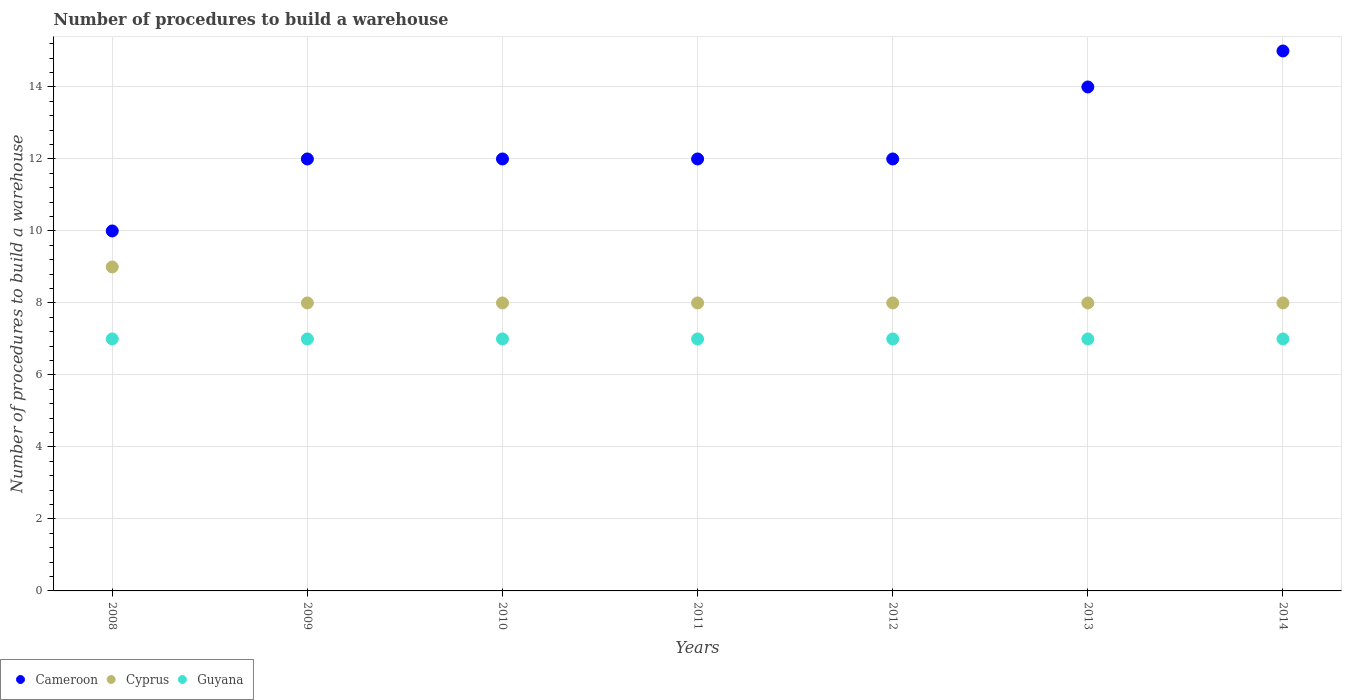Is the number of dotlines equal to the number of legend labels?
Your answer should be very brief. Yes. What is the number of procedures to build a warehouse in in Cameroon in 2009?
Offer a terse response. 12. Across all years, what is the minimum number of procedures to build a warehouse in in Guyana?
Provide a short and direct response. 7. In which year was the number of procedures to build a warehouse in in Cyprus maximum?
Give a very brief answer. 2008. In which year was the number of procedures to build a warehouse in in Cameroon minimum?
Your answer should be very brief. 2008. What is the total number of procedures to build a warehouse in in Guyana in the graph?
Ensure brevity in your answer.  49. What is the difference between the number of procedures to build a warehouse in in Cameroon in 2011 and that in 2013?
Give a very brief answer. -2. What is the difference between the number of procedures to build a warehouse in in Cameroon in 2011 and the number of procedures to build a warehouse in in Guyana in 2012?
Provide a short and direct response. 5. What is the average number of procedures to build a warehouse in in Cyprus per year?
Provide a short and direct response. 8.14. In the year 2012, what is the difference between the number of procedures to build a warehouse in in Guyana and number of procedures to build a warehouse in in Cameroon?
Give a very brief answer. -5. What is the ratio of the number of procedures to build a warehouse in in Cyprus in 2012 to that in 2013?
Provide a short and direct response. 1. Is the number of procedures to build a warehouse in in Guyana in 2009 less than that in 2013?
Ensure brevity in your answer.  No. Is the difference between the number of procedures to build a warehouse in in Guyana in 2012 and 2014 greater than the difference between the number of procedures to build a warehouse in in Cameroon in 2012 and 2014?
Offer a terse response. Yes. What is the difference between the highest and the lowest number of procedures to build a warehouse in in Cameroon?
Offer a terse response. 5. In how many years, is the number of procedures to build a warehouse in in Cyprus greater than the average number of procedures to build a warehouse in in Cyprus taken over all years?
Provide a short and direct response. 1. Is the sum of the number of procedures to build a warehouse in in Cameroon in 2011 and 2014 greater than the maximum number of procedures to build a warehouse in in Cyprus across all years?
Your answer should be very brief. Yes. Is it the case that in every year, the sum of the number of procedures to build a warehouse in in Cameroon and number of procedures to build a warehouse in in Guyana  is greater than the number of procedures to build a warehouse in in Cyprus?
Keep it short and to the point. Yes. Does the number of procedures to build a warehouse in in Cyprus monotonically increase over the years?
Make the answer very short. No. How many dotlines are there?
Your answer should be very brief. 3. Are the values on the major ticks of Y-axis written in scientific E-notation?
Offer a very short reply. No. Where does the legend appear in the graph?
Make the answer very short. Bottom left. How are the legend labels stacked?
Provide a short and direct response. Horizontal. What is the title of the graph?
Provide a succinct answer. Number of procedures to build a warehouse. Does "Turks and Caicos Islands" appear as one of the legend labels in the graph?
Keep it short and to the point. No. What is the label or title of the X-axis?
Your response must be concise. Years. What is the label or title of the Y-axis?
Your response must be concise. Number of procedures to build a warehouse. What is the Number of procedures to build a warehouse of Cyprus in 2008?
Make the answer very short. 9. What is the Number of procedures to build a warehouse of Guyana in 2008?
Keep it short and to the point. 7. What is the Number of procedures to build a warehouse of Cameroon in 2009?
Give a very brief answer. 12. What is the Number of procedures to build a warehouse in Guyana in 2009?
Your answer should be compact. 7. What is the Number of procedures to build a warehouse in Cameroon in 2010?
Offer a very short reply. 12. What is the Number of procedures to build a warehouse in Cyprus in 2010?
Keep it short and to the point. 8. What is the Number of procedures to build a warehouse of Guyana in 2010?
Offer a very short reply. 7. What is the Number of procedures to build a warehouse in Cameroon in 2011?
Provide a succinct answer. 12. What is the Number of procedures to build a warehouse of Cameroon in 2012?
Your response must be concise. 12. What is the Number of procedures to build a warehouse in Guyana in 2012?
Your answer should be compact. 7. What is the Number of procedures to build a warehouse in Cameroon in 2013?
Provide a succinct answer. 14. What is the Number of procedures to build a warehouse in Guyana in 2013?
Your response must be concise. 7. Across all years, what is the maximum Number of procedures to build a warehouse in Cameroon?
Offer a very short reply. 15. Across all years, what is the maximum Number of procedures to build a warehouse of Guyana?
Provide a short and direct response. 7. Across all years, what is the minimum Number of procedures to build a warehouse of Cameroon?
Your answer should be very brief. 10. Across all years, what is the minimum Number of procedures to build a warehouse in Cyprus?
Provide a short and direct response. 8. What is the total Number of procedures to build a warehouse of Guyana in the graph?
Provide a succinct answer. 49. What is the difference between the Number of procedures to build a warehouse in Guyana in 2008 and that in 2009?
Offer a very short reply. 0. What is the difference between the Number of procedures to build a warehouse in Cameroon in 2008 and that in 2010?
Provide a short and direct response. -2. What is the difference between the Number of procedures to build a warehouse of Guyana in 2008 and that in 2010?
Provide a short and direct response. 0. What is the difference between the Number of procedures to build a warehouse of Cyprus in 2008 and that in 2011?
Provide a short and direct response. 1. What is the difference between the Number of procedures to build a warehouse of Guyana in 2008 and that in 2011?
Give a very brief answer. 0. What is the difference between the Number of procedures to build a warehouse in Cameroon in 2008 and that in 2012?
Your response must be concise. -2. What is the difference between the Number of procedures to build a warehouse in Cyprus in 2008 and that in 2012?
Make the answer very short. 1. What is the difference between the Number of procedures to build a warehouse in Cyprus in 2008 and that in 2013?
Your answer should be compact. 1. What is the difference between the Number of procedures to build a warehouse in Guyana in 2008 and that in 2013?
Keep it short and to the point. 0. What is the difference between the Number of procedures to build a warehouse of Guyana in 2009 and that in 2010?
Give a very brief answer. 0. What is the difference between the Number of procedures to build a warehouse in Cameroon in 2009 and that in 2012?
Offer a very short reply. 0. What is the difference between the Number of procedures to build a warehouse of Cyprus in 2009 and that in 2012?
Your response must be concise. 0. What is the difference between the Number of procedures to build a warehouse in Guyana in 2009 and that in 2012?
Keep it short and to the point. 0. What is the difference between the Number of procedures to build a warehouse of Cameroon in 2009 and that in 2014?
Make the answer very short. -3. What is the difference between the Number of procedures to build a warehouse in Guyana in 2009 and that in 2014?
Make the answer very short. 0. What is the difference between the Number of procedures to build a warehouse of Cameroon in 2010 and that in 2011?
Give a very brief answer. 0. What is the difference between the Number of procedures to build a warehouse in Guyana in 2010 and that in 2011?
Make the answer very short. 0. What is the difference between the Number of procedures to build a warehouse in Cameroon in 2010 and that in 2012?
Your response must be concise. 0. What is the difference between the Number of procedures to build a warehouse of Cyprus in 2010 and that in 2012?
Make the answer very short. 0. What is the difference between the Number of procedures to build a warehouse of Guyana in 2010 and that in 2012?
Offer a very short reply. 0. What is the difference between the Number of procedures to build a warehouse of Cameroon in 2010 and that in 2013?
Offer a terse response. -2. What is the difference between the Number of procedures to build a warehouse of Cyprus in 2010 and that in 2013?
Your answer should be very brief. 0. What is the difference between the Number of procedures to build a warehouse in Guyana in 2010 and that in 2014?
Make the answer very short. 0. What is the difference between the Number of procedures to build a warehouse in Guyana in 2011 and that in 2012?
Provide a short and direct response. 0. What is the difference between the Number of procedures to build a warehouse of Cameroon in 2011 and that in 2013?
Offer a very short reply. -2. What is the difference between the Number of procedures to build a warehouse in Cameroon in 2011 and that in 2014?
Offer a very short reply. -3. What is the difference between the Number of procedures to build a warehouse of Cameroon in 2012 and that in 2013?
Provide a short and direct response. -2. What is the difference between the Number of procedures to build a warehouse in Cyprus in 2012 and that in 2013?
Your response must be concise. 0. What is the difference between the Number of procedures to build a warehouse of Guyana in 2012 and that in 2013?
Provide a short and direct response. 0. What is the difference between the Number of procedures to build a warehouse of Cyprus in 2012 and that in 2014?
Provide a short and direct response. 0. What is the difference between the Number of procedures to build a warehouse of Guyana in 2012 and that in 2014?
Make the answer very short. 0. What is the difference between the Number of procedures to build a warehouse of Cameroon in 2008 and the Number of procedures to build a warehouse of Guyana in 2010?
Make the answer very short. 3. What is the difference between the Number of procedures to build a warehouse in Cyprus in 2008 and the Number of procedures to build a warehouse in Guyana in 2010?
Give a very brief answer. 2. What is the difference between the Number of procedures to build a warehouse in Cameroon in 2008 and the Number of procedures to build a warehouse in Cyprus in 2011?
Keep it short and to the point. 2. What is the difference between the Number of procedures to build a warehouse of Cameroon in 2008 and the Number of procedures to build a warehouse of Cyprus in 2013?
Your answer should be compact. 2. What is the difference between the Number of procedures to build a warehouse in Cameroon in 2008 and the Number of procedures to build a warehouse in Guyana in 2013?
Your answer should be compact. 3. What is the difference between the Number of procedures to build a warehouse of Cyprus in 2008 and the Number of procedures to build a warehouse of Guyana in 2013?
Your response must be concise. 2. What is the difference between the Number of procedures to build a warehouse in Cameroon in 2008 and the Number of procedures to build a warehouse in Cyprus in 2014?
Ensure brevity in your answer.  2. What is the difference between the Number of procedures to build a warehouse of Cyprus in 2008 and the Number of procedures to build a warehouse of Guyana in 2014?
Your answer should be very brief. 2. What is the difference between the Number of procedures to build a warehouse of Cameroon in 2009 and the Number of procedures to build a warehouse of Guyana in 2010?
Your answer should be very brief. 5. What is the difference between the Number of procedures to build a warehouse in Cameroon in 2009 and the Number of procedures to build a warehouse in Cyprus in 2011?
Your response must be concise. 4. What is the difference between the Number of procedures to build a warehouse of Cyprus in 2009 and the Number of procedures to build a warehouse of Guyana in 2011?
Your answer should be very brief. 1. What is the difference between the Number of procedures to build a warehouse in Cameroon in 2009 and the Number of procedures to build a warehouse in Guyana in 2013?
Provide a short and direct response. 5. What is the difference between the Number of procedures to build a warehouse of Cameroon in 2009 and the Number of procedures to build a warehouse of Cyprus in 2014?
Keep it short and to the point. 4. What is the difference between the Number of procedures to build a warehouse in Cameroon in 2009 and the Number of procedures to build a warehouse in Guyana in 2014?
Provide a succinct answer. 5. What is the difference between the Number of procedures to build a warehouse of Cyprus in 2009 and the Number of procedures to build a warehouse of Guyana in 2014?
Offer a terse response. 1. What is the difference between the Number of procedures to build a warehouse of Cameroon in 2010 and the Number of procedures to build a warehouse of Cyprus in 2011?
Provide a succinct answer. 4. What is the difference between the Number of procedures to build a warehouse of Cyprus in 2010 and the Number of procedures to build a warehouse of Guyana in 2011?
Offer a terse response. 1. What is the difference between the Number of procedures to build a warehouse in Cameroon in 2010 and the Number of procedures to build a warehouse in Cyprus in 2012?
Offer a terse response. 4. What is the difference between the Number of procedures to build a warehouse in Cyprus in 2010 and the Number of procedures to build a warehouse in Guyana in 2012?
Make the answer very short. 1. What is the difference between the Number of procedures to build a warehouse of Cameroon in 2010 and the Number of procedures to build a warehouse of Cyprus in 2013?
Your response must be concise. 4. What is the difference between the Number of procedures to build a warehouse in Cyprus in 2010 and the Number of procedures to build a warehouse in Guyana in 2013?
Provide a succinct answer. 1. What is the difference between the Number of procedures to build a warehouse in Cameroon in 2010 and the Number of procedures to build a warehouse in Guyana in 2014?
Offer a terse response. 5. What is the difference between the Number of procedures to build a warehouse of Cameroon in 2011 and the Number of procedures to build a warehouse of Cyprus in 2012?
Your answer should be very brief. 4. What is the difference between the Number of procedures to build a warehouse in Cameroon in 2011 and the Number of procedures to build a warehouse in Guyana in 2012?
Provide a succinct answer. 5. What is the difference between the Number of procedures to build a warehouse of Cyprus in 2011 and the Number of procedures to build a warehouse of Guyana in 2012?
Your response must be concise. 1. What is the difference between the Number of procedures to build a warehouse of Cyprus in 2011 and the Number of procedures to build a warehouse of Guyana in 2014?
Provide a succinct answer. 1. What is the difference between the Number of procedures to build a warehouse of Cameroon in 2012 and the Number of procedures to build a warehouse of Cyprus in 2013?
Keep it short and to the point. 4. What is the difference between the Number of procedures to build a warehouse of Cyprus in 2012 and the Number of procedures to build a warehouse of Guyana in 2013?
Offer a very short reply. 1. What is the difference between the Number of procedures to build a warehouse of Cameroon in 2013 and the Number of procedures to build a warehouse of Cyprus in 2014?
Keep it short and to the point. 6. What is the difference between the Number of procedures to build a warehouse of Cameroon in 2013 and the Number of procedures to build a warehouse of Guyana in 2014?
Offer a very short reply. 7. What is the difference between the Number of procedures to build a warehouse of Cyprus in 2013 and the Number of procedures to build a warehouse of Guyana in 2014?
Provide a succinct answer. 1. What is the average Number of procedures to build a warehouse in Cameroon per year?
Keep it short and to the point. 12.43. What is the average Number of procedures to build a warehouse of Cyprus per year?
Provide a short and direct response. 8.14. What is the average Number of procedures to build a warehouse of Guyana per year?
Provide a short and direct response. 7. In the year 2008, what is the difference between the Number of procedures to build a warehouse in Cameroon and Number of procedures to build a warehouse in Cyprus?
Your answer should be very brief. 1. In the year 2008, what is the difference between the Number of procedures to build a warehouse in Cameroon and Number of procedures to build a warehouse in Guyana?
Provide a short and direct response. 3. In the year 2009, what is the difference between the Number of procedures to build a warehouse of Cameroon and Number of procedures to build a warehouse of Guyana?
Your answer should be compact. 5. In the year 2010, what is the difference between the Number of procedures to build a warehouse in Cameroon and Number of procedures to build a warehouse in Cyprus?
Your answer should be very brief. 4. In the year 2010, what is the difference between the Number of procedures to build a warehouse of Cameroon and Number of procedures to build a warehouse of Guyana?
Provide a short and direct response. 5. In the year 2011, what is the difference between the Number of procedures to build a warehouse of Cyprus and Number of procedures to build a warehouse of Guyana?
Make the answer very short. 1. In the year 2012, what is the difference between the Number of procedures to build a warehouse of Cameroon and Number of procedures to build a warehouse of Cyprus?
Keep it short and to the point. 4. In the year 2012, what is the difference between the Number of procedures to build a warehouse in Cyprus and Number of procedures to build a warehouse in Guyana?
Your answer should be compact. 1. In the year 2013, what is the difference between the Number of procedures to build a warehouse in Cameroon and Number of procedures to build a warehouse in Guyana?
Offer a terse response. 7. In the year 2014, what is the difference between the Number of procedures to build a warehouse of Cameroon and Number of procedures to build a warehouse of Guyana?
Your answer should be compact. 8. What is the ratio of the Number of procedures to build a warehouse in Cameroon in 2008 to that in 2009?
Provide a short and direct response. 0.83. What is the ratio of the Number of procedures to build a warehouse of Guyana in 2008 to that in 2009?
Give a very brief answer. 1. What is the ratio of the Number of procedures to build a warehouse of Cameroon in 2008 to that in 2010?
Your answer should be compact. 0.83. What is the ratio of the Number of procedures to build a warehouse in Guyana in 2008 to that in 2011?
Make the answer very short. 1. What is the ratio of the Number of procedures to build a warehouse of Guyana in 2008 to that in 2012?
Give a very brief answer. 1. What is the ratio of the Number of procedures to build a warehouse in Cameroon in 2008 to that in 2013?
Give a very brief answer. 0.71. What is the ratio of the Number of procedures to build a warehouse in Cyprus in 2008 to that in 2013?
Provide a succinct answer. 1.12. What is the ratio of the Number of procedures to build a warehouse of Guyana in 2008 to that in 2013?
Your answer should be very brief. 1. What is the ratio of the Number of procedures to build a warehouse of Cyprus in 2008 to that in 2014?
Your response must be concise. 1.12. What is the ratio of the Number of procedures to build a warehouse in Cameroon in 2009 to that in 2010?
Make the answer very short. 1. What is the ratio of the Number of procedures to build a warehouse in Cyprus in 2009 to that in 2010?
Offer a terse response. 1. What is the ratio of the Number of procedures to build a warehouse of Cameroon in 2009 to that in 2011?
Offer a very short reply. 1. What is the ratio of the Number of procedures to build a warehouse of Cameroon in 2009 to that in 2012?
Offer a very short reply. 1. What is the ratio of the Number of procedures to build a warehouse in Guyana in 2009 to that in 2012?
Your response must be concise. 1. What is the ratio of the Number of procedures to build a warehouse of Cameroon in 2010 to that in 2011?
Keep it short and to the point. 1. What is the ratio of the Number of procedures to build a warehouse of Guyana in 2010 to that in 2011?
Offer a very short reply. 1. What is the ratio of the Number of procedures to build a warehouse in Cyprus in 2010 to that in 2013?
Ensure brevity in your answer.  1. What is the ratio of the Number of procedures to build a warehouse of Guyana in 2010 to that in 2013?
Offer a terse response. 1. What is the ratio of the Number of procedures to build a warehouse of Cameroon in 2010 to that in 2014?
Your answer should be compact. 0.8. What is the ratio of the Number of procedures to build a warehouse of Cyprus in 2011 to that in 2012?
Your response must be concise. 1. What is the ratio of the Number of procedures to build a warehouse in Cameroon in 2011 to that in 2013?
Offer a terse response. 0.86. What is the ratio of the Number of procedures to build a warehouse in Cyprus in 2011 to that in 2013?
Make the answer very short. 1. What is the ratio of the Number of procedures to build a warehouse in Cyprus in 2011 to that in 2014?
Your answer should be very brief. 1. What is the ratio of the Number of procedures to build a warehouse of Guyana in 2011 to that in 2014?
Your response must be concise. 1. What is the ratio of the Number of procedures to build a warehouse in Guyana in 2012 to that in 2014?
Offer a very short reply. 1. What is the difference between the highest and the second highest Number of procedures to build a warehouse in Cameroon?
Your response must be concise. 1. What is the difference between the highest and the second highest Number of procedures to build a warehouse of Cyprus?
Keep it short and to the point. 1. What is the difference between the highest and the second highest Number of procedures to build a warehouse in Guyana?
Offer a terse response. 0. What is the difference between the highest and the lowest Number of procedures to build a warehouse in Cameroon?
Make the answer very short. 5. What is the difference between the highest and the lowest Number of procedures to build a warehouse in Cyprus?
Provide a succinct answer. 1. What is the difference between the highest and the lowest Number of procedures to build a warehouse of Guyana?
Your answer should be very brief. 0. 